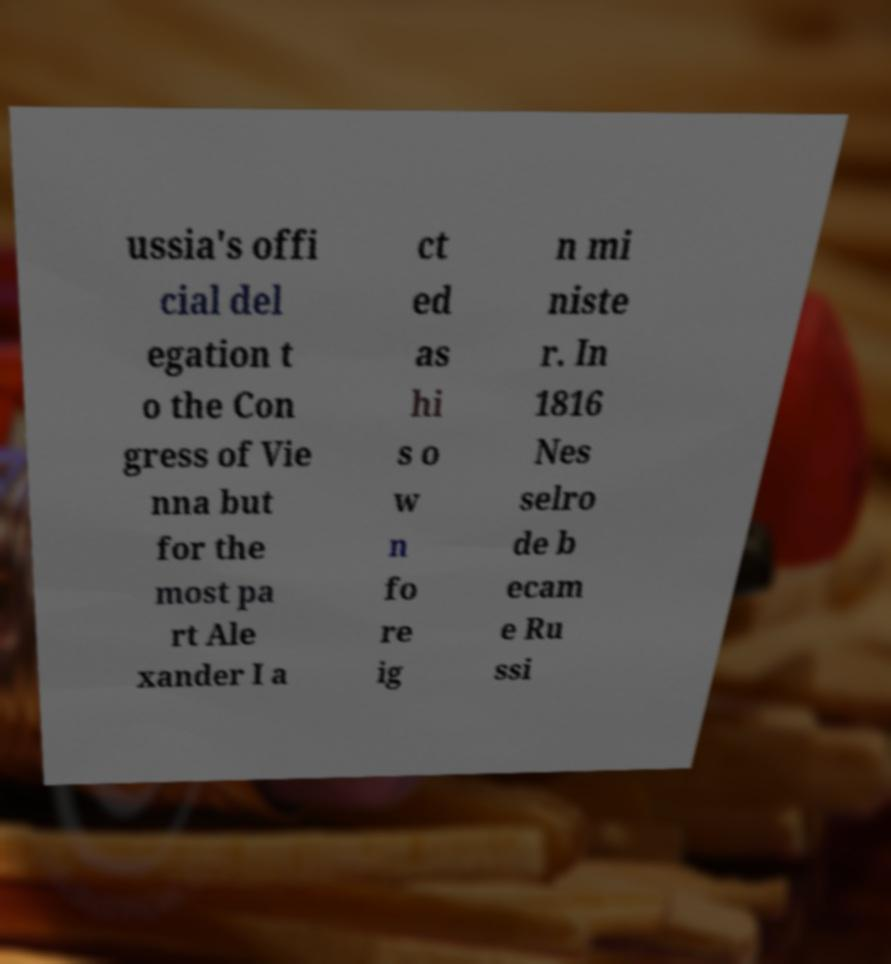Please identify and transcribe the text found in this image. ussia's offi cial del egation t o the Con gress of Vie nna but for the most pa rt Ale xander I a ct ed as hi s o w n fo re ig n mi niste r. In 1816 Nes selro de b ecam e Ru ssi 